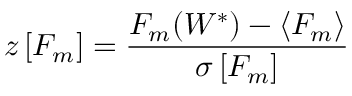Convert formula to latex. <formula><loc_0><loc_0><loc_500><loc_500>z \left [ F _ { m } \right ] = \frac { F _ { m } ( W ^ { * } ) - \langle F _ { m } \rangle } { \sigma \left [ F _ { m } \right ] }</formula> 